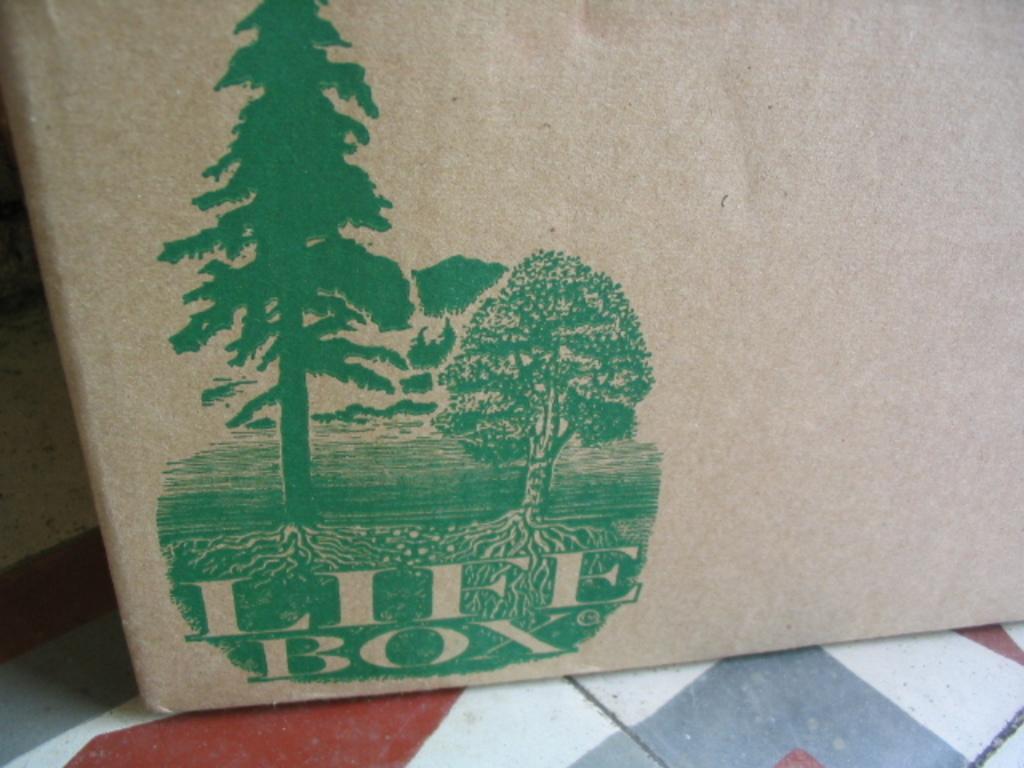How would you summarize this image in a sentence or two? his image consist of a cover which is in the center and there is a print on the cover with some text on it. 